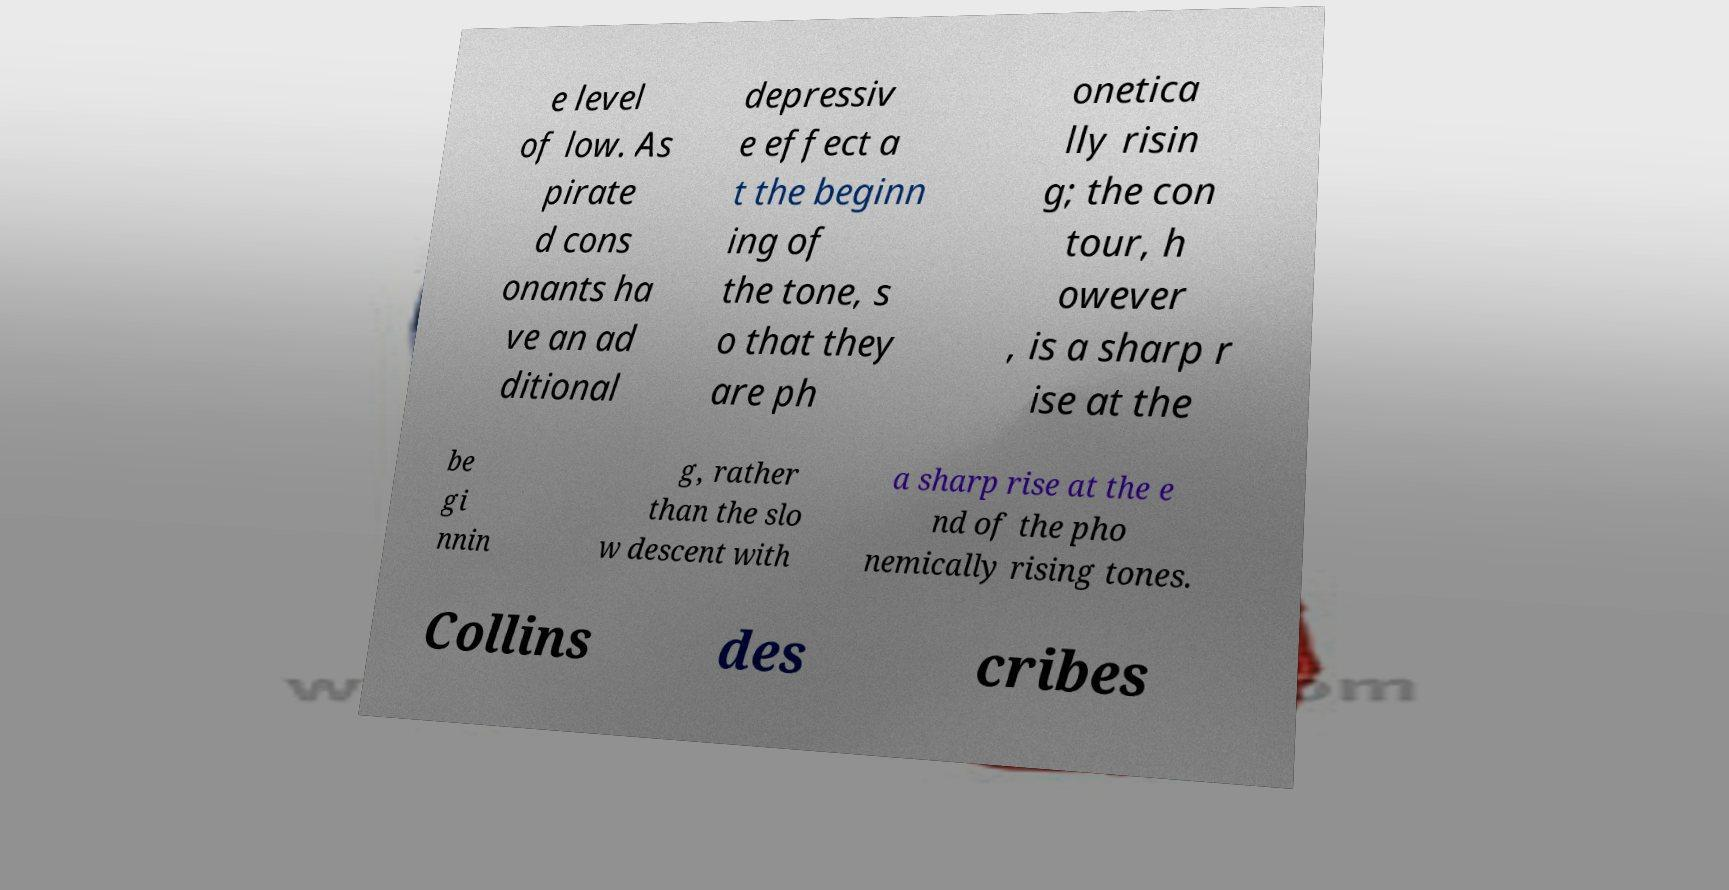Please identify and transcribe the text found in this image. e level of low. As pirate d cons onants ha ve an ad ditional depressiv e effect a t the beginn ing of the tone, s o that they are ph onetica lly risin g; the con tour, h owever , is a sharp r ise at the be gi nnin g, rather than the slo w descent with a sharp rise at the e nd of the pho nemically rising tones. Collins des cribes 